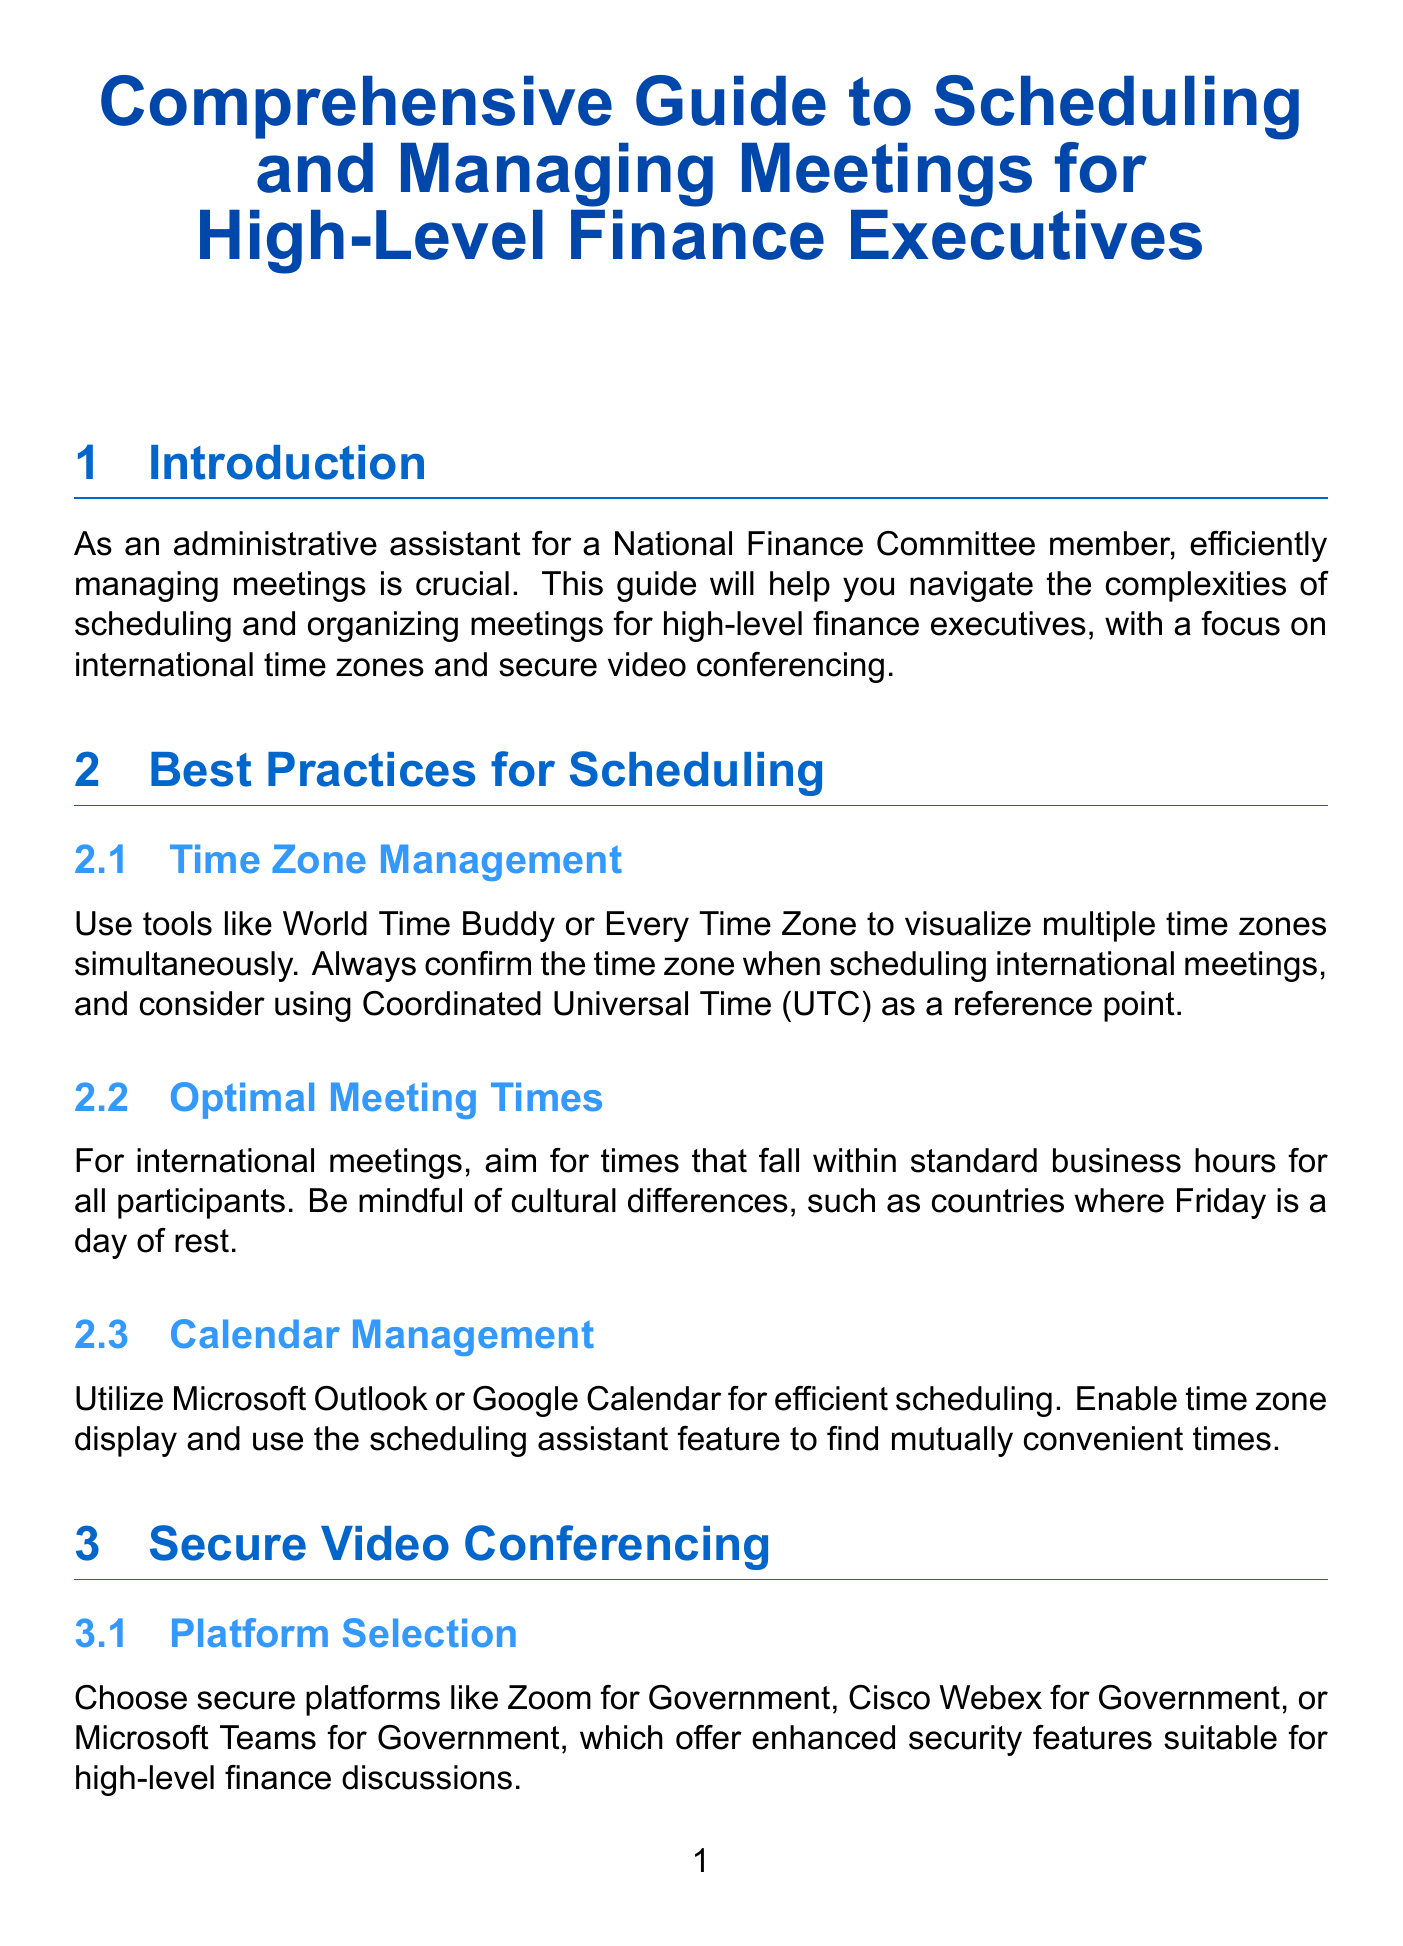What is the title of the manual? The title of the manual is provided at the beginning of the document.
Answer: Comprehensive Guide to Scheduling and Managing Meetings for High-Level Finance Executives What is a recommended tool for visualization of multiple time zones? The document lists tools specifically for time zone management, one of which is mentioned.
Answer: World Time Buddy What security measures should always be used? The document outlines specific security measures that need to be implemented for secure video conferencing.
Answer: Password protection Who should create the agenda? The document specifies who should collaborate on creating the agenda for the meeting.
Answer: Finance executive What is a recommended tool for note-taking? The section on note-taking suggests specific tools for this task.
Answer: Microsoft OneNote How long before the meeting should a test call be conducted? The document states a specific time frame for conducting a test call before a meeting starts.
Answer: 15-30 minutes What is the ideal time frame to send out meeting minutes? The document recommends a specific duration for sending out meeting minutes after the meeting concludes.
Answer: Within 24 hours Which act should one familiarize themselves with regarding compliance regulations? The document lists particular financial regulations that are important for compliance.
Answer: Sarbanes-Oxley Act What is one of the suggested platforms for secure video conferencing? The manual provides examples of secure platforms ideal for high-level finance discussions.
Answer: Zoom for Government 